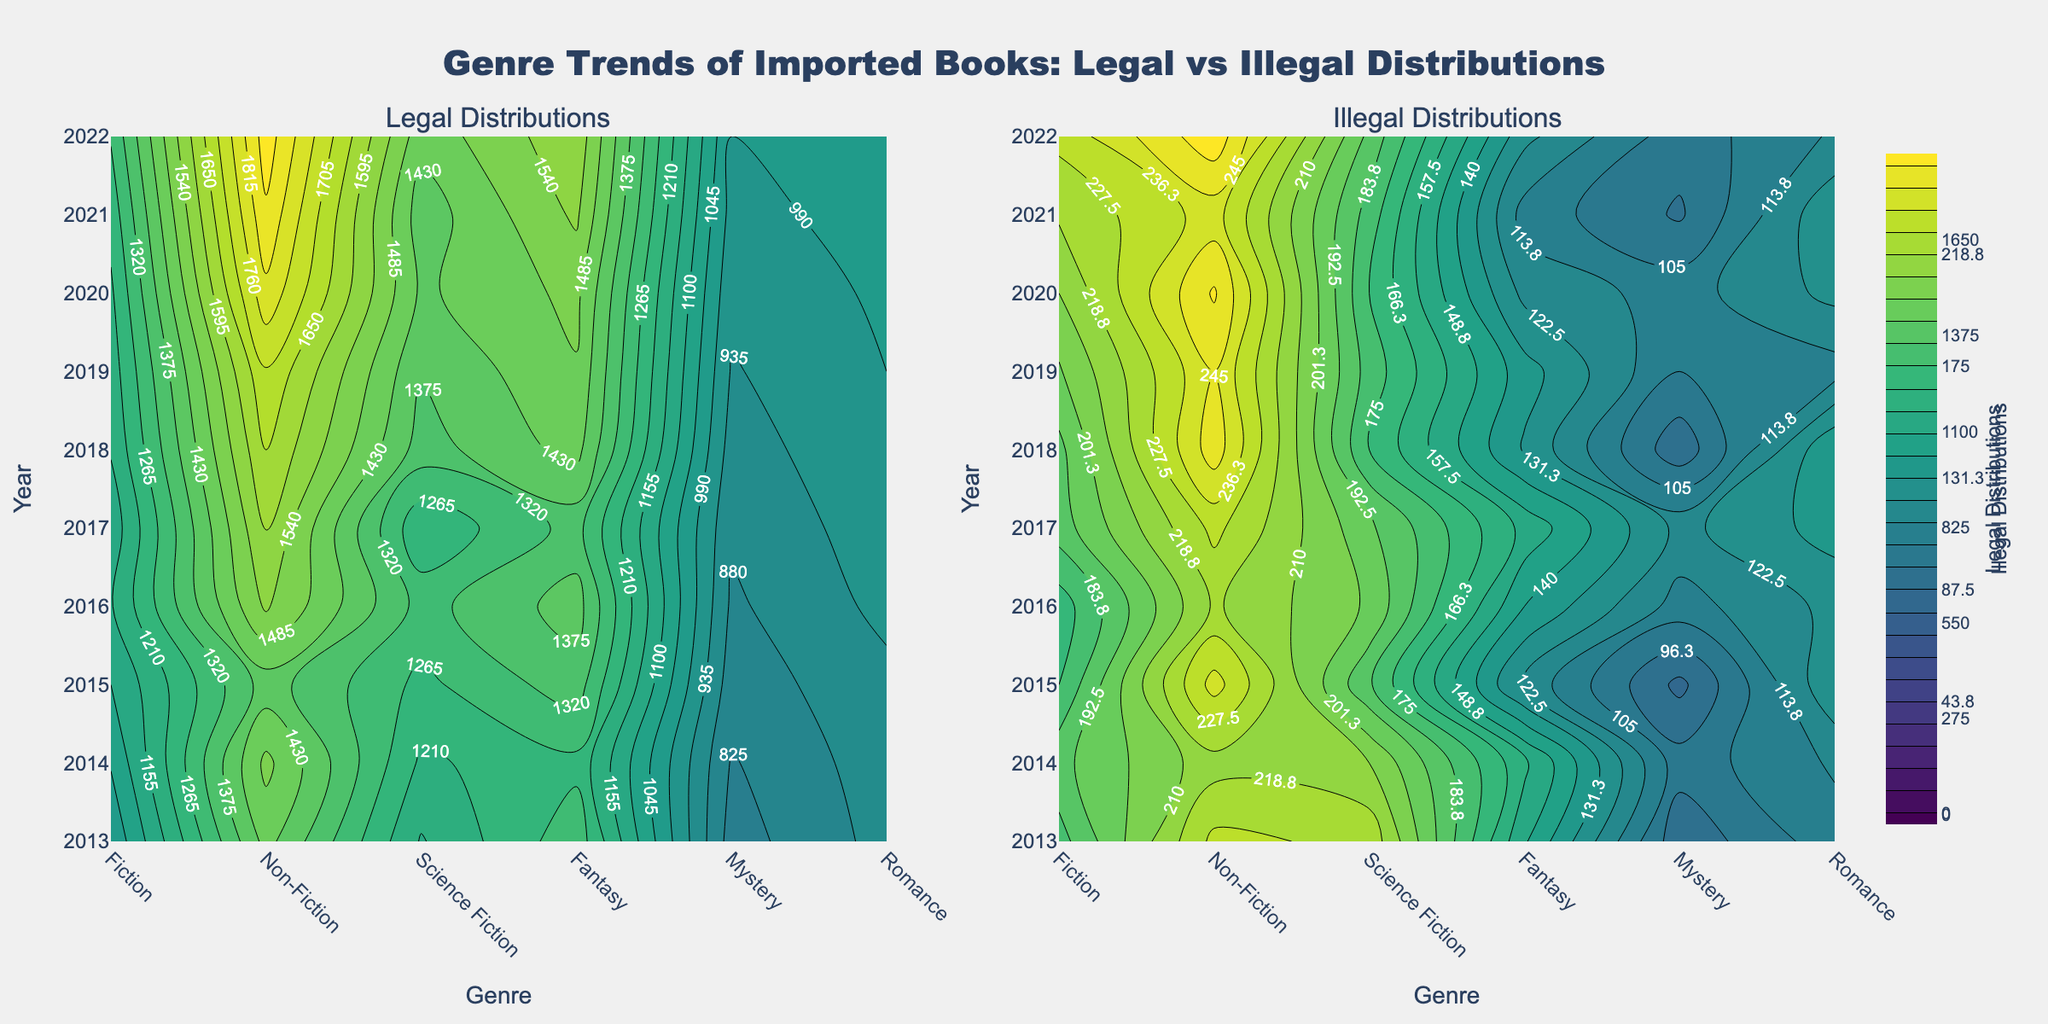How many genres are displayed in the figure? The x-axis of the contour plots displays the distinct genres: Fiction, Non-Fiction, Science Fiction, Fantasy, Mystery, and Romance. Counting these gives the total number of genres.
Answer: 6 In which year did Fiction have the highest legal distributions? By following the contour lines on the 'Legal Distributions' subplot, note that the highest point for Fiction corresponds to the year labeled on the y-axis. Fiction's peak value is reached around 2022.
Answer: 2022 Compare Fantasy and Science Fiction genres in terms of illegal distributions over the past decade. Which genre had a greater increase? By observing the 'Illegal Distributions' subplot, trace the contour lines for Fantasy and Science Fiction from 2013 to 2022. Noticing their starting and ending values suggests that Fantasy shows a more significant increase over the years.
Answer: Fantasy Which genre shows the smallest variability in legal distributions over the years? Inspecting the 'Legal Distributions' contour subplot, identify the genre with the most uniformly spaced contour lines or minimal gradient. Romance generally maintains uniformity in distribution heights compared to others.
Answer: Romance In what year did Mystery legal distributions surpass 1400? Look at the contour lines' progression on the 'Legal Distributions' subplot focused on Mystery. The contour lines show that Mystery surpasses 1400 around the year indicated on the y-axis. This happens around 2020.
Answer: 2020 Considering the Illegal Distributions subplot, which genre had the highest peak value and in which year? By scanning the 'Illegal Distributions' contour subplot and finding the highest density of contours and matching it to the corresponding year and genre. Fiction, particularly in the year 2022, shows the highest peak value.
Answer: Fiction, 2022 How do illegal distributions for Non-Fiction compare between 2013 and 2022? Following the contour lines on the 'Illegal Distributions' subplot for Non-Fiction at the year labels 2013 and 2022. Non-Fiction starts at around 150 in 2013 and reaches approximately 125 in 2022, indicating a decrease.
Answer: Decrease What trend can be observed in the legal distributions of Romance books? Observing the Romance contour in the 'Legal Distributions' subplot from 2013 to 2022. The contour lines show a steady upward trend indicating an increase in legal distributions over the years.
Answer: Increasing trend Which genre experienced the smallest amount of illegal distributions in 2020? On the 'Illegal Distributions' subplot, find the year 2020 along the y-axis and look across the six genres. The smallest value is indicated for Romance in 2020.
Answer: Romance 